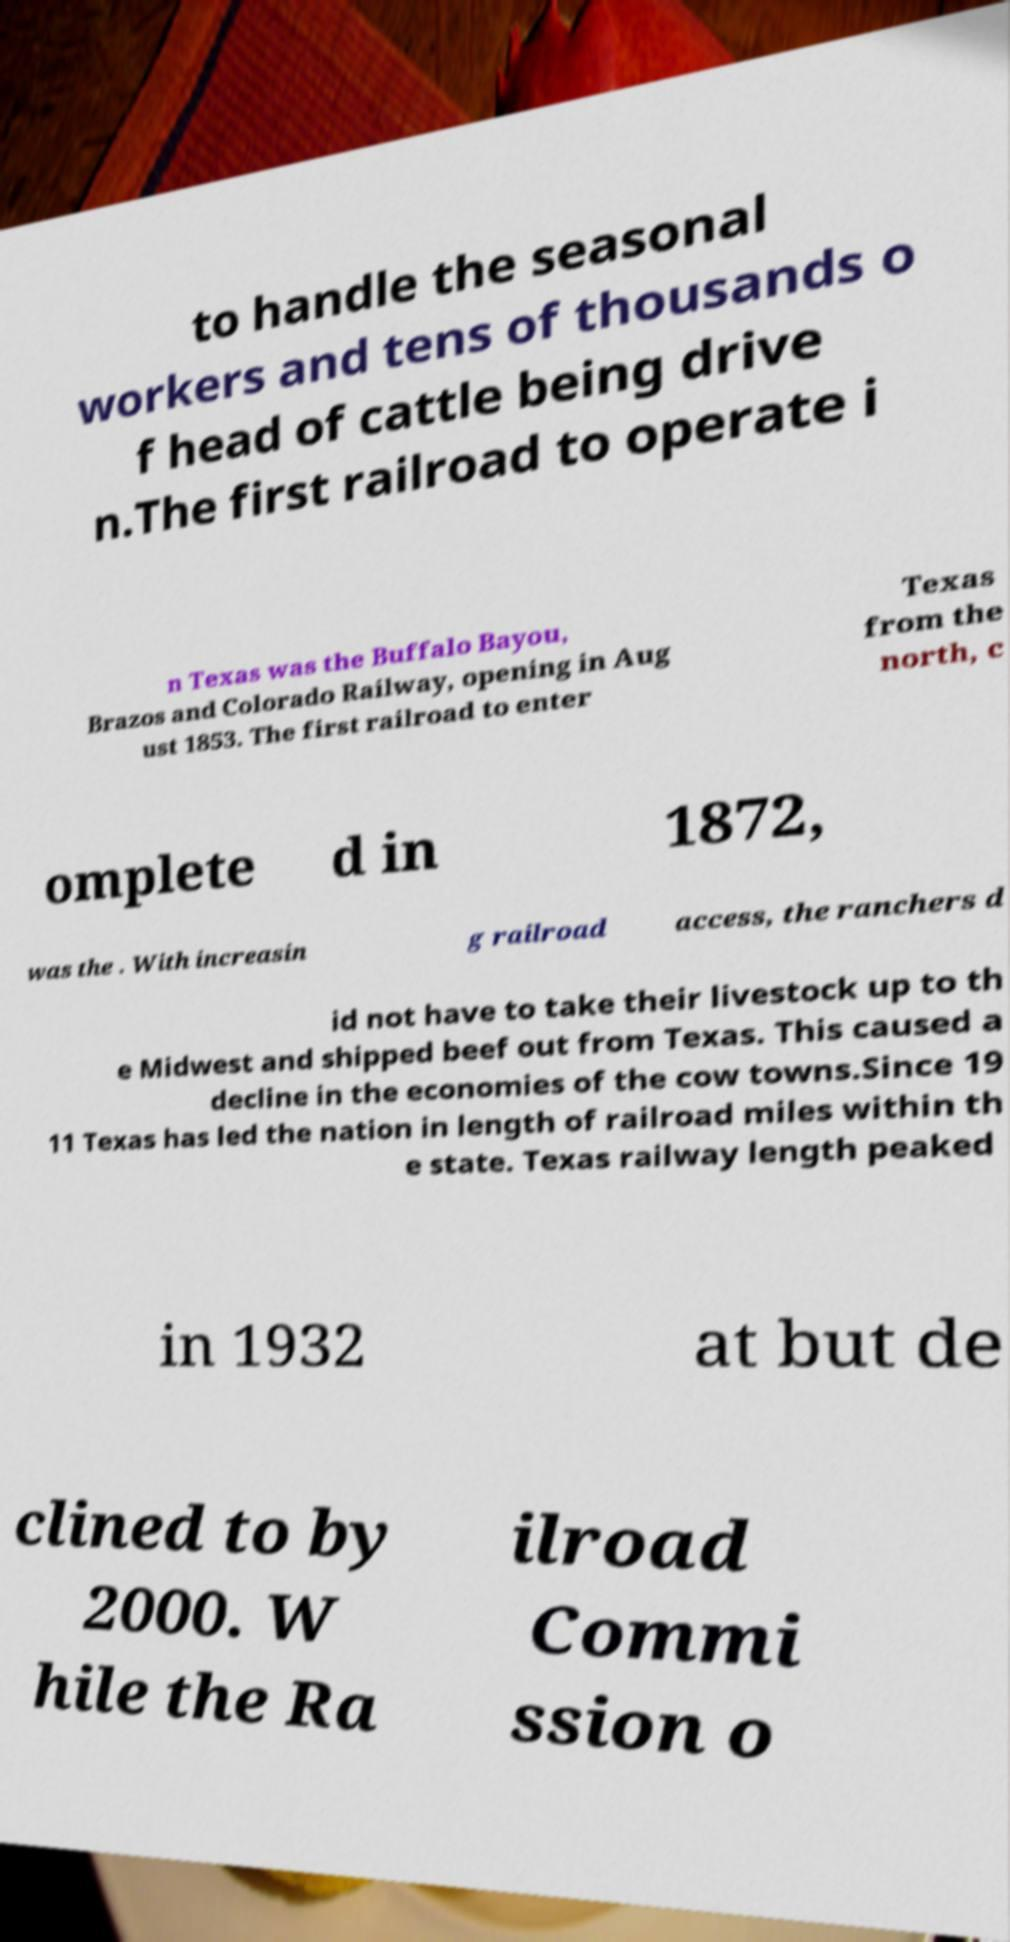For documentation purposes, I need the text within this image transcribed. Could you provide that? to handle the seasonal workers and tens of thousands o f head of cattle being drive n.The first railroad to operate i n Texas was the Buffalo Bayou, Brazos and Colorado Railway, opening in Aug ust 1853. The first railroad to enter Texas from the north, c omplete d in 1872, was the . With increasin g railroad access, the ranchers d id not have to take their livestock up to th e Midwest and shipped beef out from Texas. This caused a decline in the economies of the cow towns.Since 19 11 Texas has led the nation in length of railroad miles within th e state. Texas railway length peaked in 1932 at but de clined to by 2000. W hile the Ra ilroad Commi ssion o 